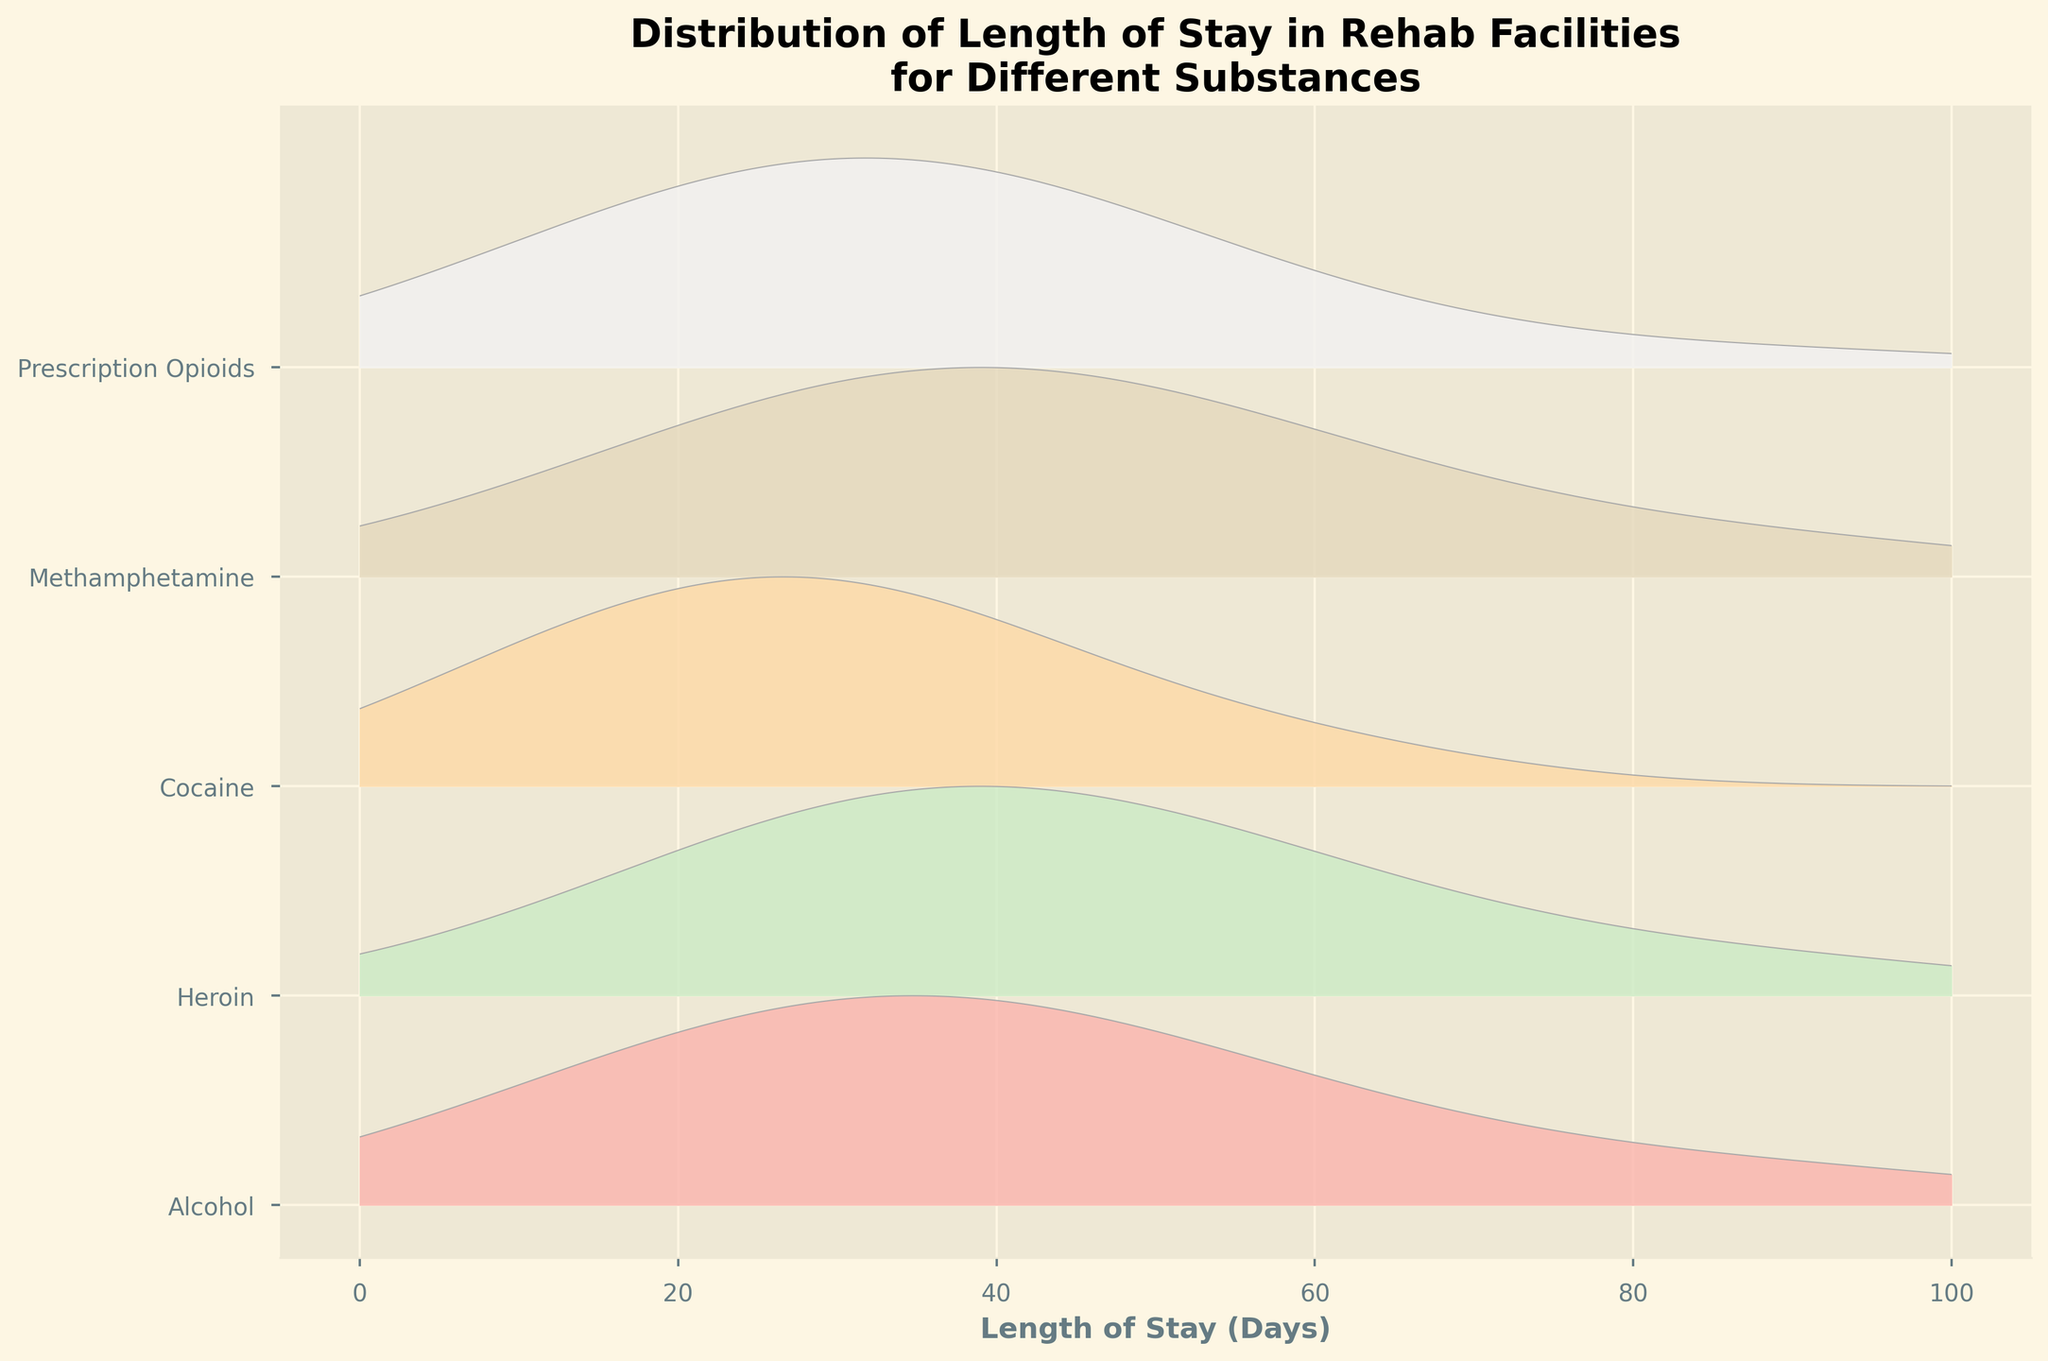What's the title of the figure? The title is usually located at the top of the figure. It denotes the main topic the graph is representing. In this case, you can read it clearly at the top.
Answer: Distribution of Length of Stay in Rehab Facilities for Different Substances What are the x-axis and y-axis labels? Axis labels are typically found adjacent to the axes. The x-axis label is at the bottom, and the y-axis label is at the left side.
Answer: x-axis: Length of Stay (Days), y-axis: Substance types How many different substances are represented in the plot? By checking the y-axis, you can count the number of different labels present there. This gives the number of substances plotted.
Answer: Five Which substance shows the highest peak at a 28-day stay? To identify which substance has the highest density at 28 days, find the peaks of the curves at the 28-day mark and compare their heights. The substance with the tallest peak is the answer.
Answer: Cocaine Between Alcohol and Heroin, which substance has a higher frequency for a 42-day stay? Compare the heights of the ridgelines representing Alcohol and Heroin at the 42-day stay juncture. The taller peak indicates a higher frequency.
Answer: Heroin What is the range of days considered for length of stay in this figure? The x-axis specifies the range of days. The minimum and maximum values on this axis denote the range of days considered.
Answer: 0 to 100 days Which substance has the most balanced distribution across different lengths of stay? A balanced distribution would have similar peak heights across different lengths of stay. This can be identified by looking for the substance with relatively equal peak heights.
Answer: Prescription Opioids Which substance has the least variation in length of stay? Look for the substance where the peaks of the ridgeline are the tallest and narrowest, indicating less variation.
Answer: Alcohol Which two substances have a noticeable peak around 60 days of stay? Identify the substances whose ridgelines have visible peaks around the 60-day mark by examining the curves at this point and identifying the spikes.
Answer: Heroin and Methamphetamine 